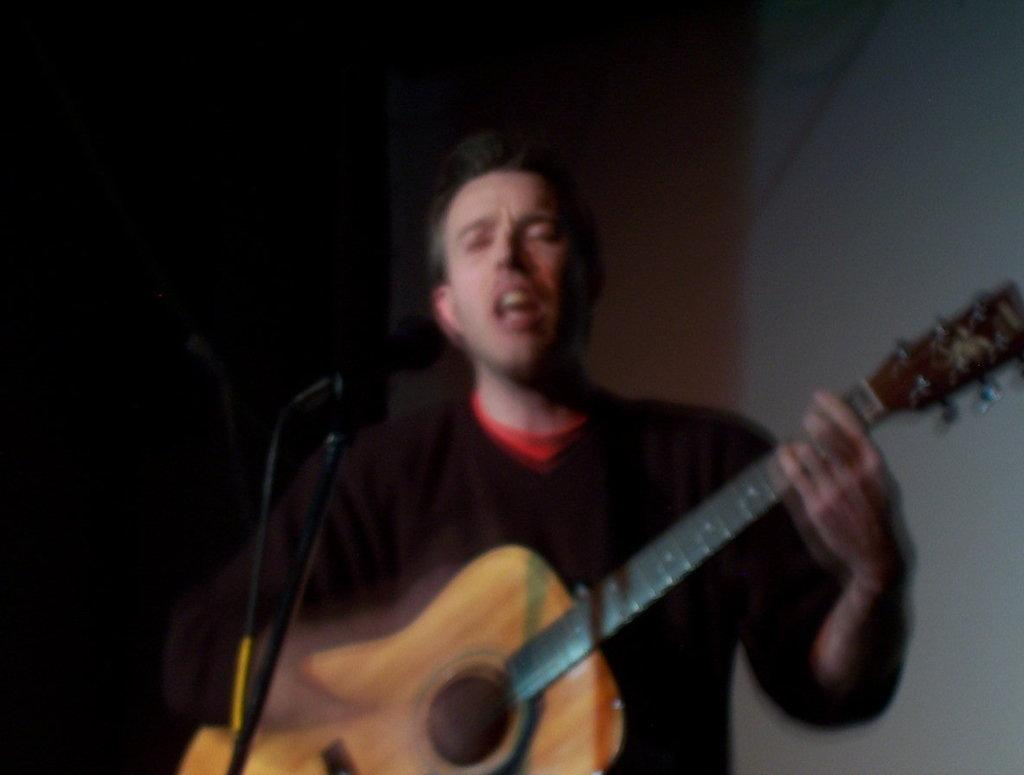What is the main subject of the image? The main subject of the image is a person. What is the person doing in the image? The person is standing in the image. What object is the person holding in their hand? The person is holding a guitar in their hand. What type of knowledge is the person sharing with their father in the image? There is no indication in the image that the person is sharing knowledge with their father, as there is no reference to a father or any knowledge being shared. 